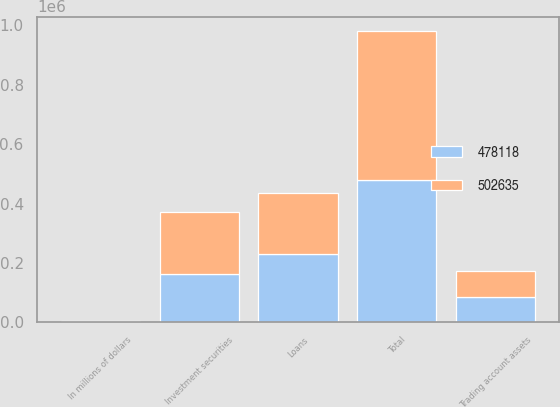<chart> <loc_0><loc_0><loc_500><loc_500><stacked_bar_chart><ecel><fcel>In millions of dollars<fcel>Investment securities<fcel>Loans<fcel>Trading account assets<fcel>Total<nl><fcel>478118<fcel>2016<fcel>161914<fcel>231833<fcel>84371<fcel>478118<nl><fcel>502635<fcel>2015<fcel>210604<fcel>203568<fcel>88463<fcel>502635<nl></chart> 